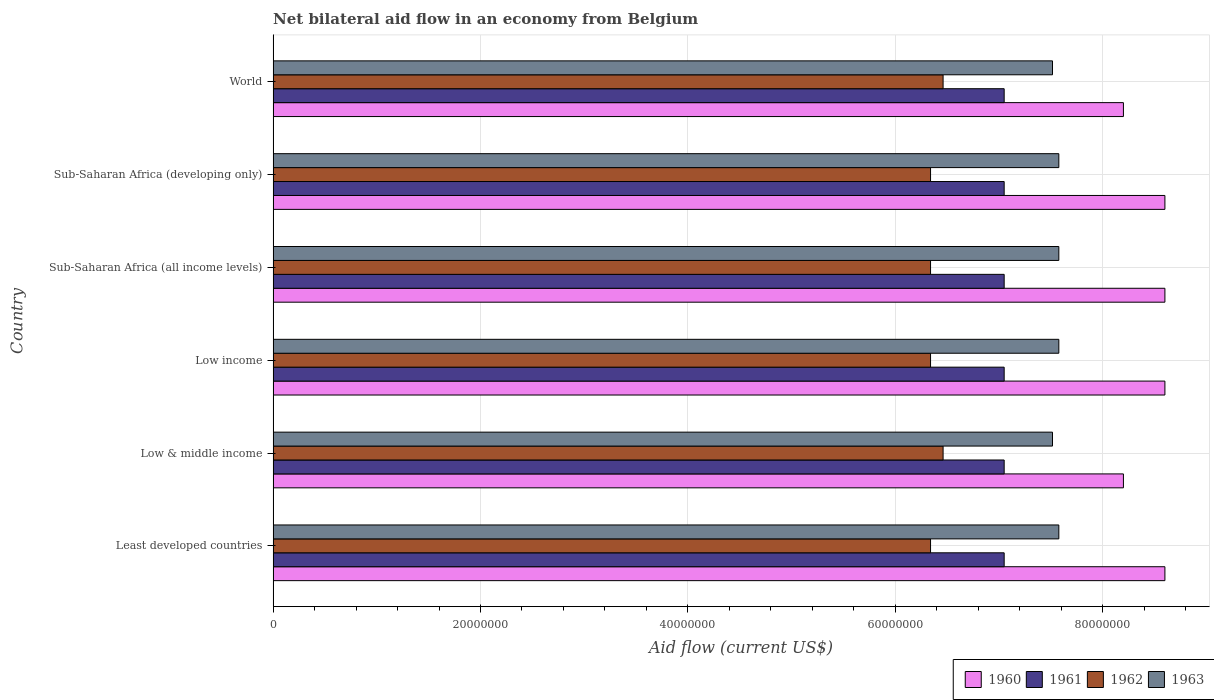How many different coloured bars are there?
Provide a short and direct response. 4. Are the number of bars per tick equal to the number of legend labels?
Offer a terse response. Yes. Are the number of bars on each tick of the Y-axis equal?
Ensure brevity in your answer.  Yes. What is the label of the 4th group of bars from the top?
Provide a short and direct response. Low income. In how many cases, is the number of bars for a given country not equal to the number of legend labels?
Offer a terse response. 0. What is the net bilateral aid flow in 1960 in Low & middle income?
Offer a terse response. 8.20e+07. Across all countries, what is the maximum net bilateral aid flow in 1963?
Ensure brevity in your answer.  7.58e+07. Across all countries, what is the minimum net bilateral aid flow in 1962?
Provide a short and direct response. 6.34e+07. In which country was the net bilateral aid flow in 1963 maximum?
Your answer should be very brief. Least developed countries. What is the total net bilateral aid flow in 1960 in the graph?
Make the answer very short. 5.08e+08. What is the difference between the net bilateral aid flow in 1961 in World and the net bilateral aid flow in 1960 in Low income?
Your answer should be compact. -1.55e+07. What is the average net bilateral aid flow in 1960 per country?
Provide a short and direct response. 8.47e+07. What is the difference between the net bilateral aid flow in 1960 and net bilateral aid flow in 1961 in Sub-Saharan Africa (developing only)?
Give a very brief answer. 1.55e+07. In how many countries, is the net bilateral aid flow in 1961 greater than 64000000 US$?
Provide a short and direct response. 6. What is the difference between the highest and the second highest net bilateral aid flow in 1961?
Keep it short and to the point. 0. What is the difference between the highest and the lowest net bilateral aid flow in 1962?
Give a very brief answer. 1.21e+06. In how many countries, is the net bilateral aid flow in 1961 greater than the average net bilateral aid flow in 1961 taken over all countries?
Ensure brevity in your answer.  0. What does the 1st bar from the top in World represents?
Your answer should be very brief. 1963. How many bars are there?
Provide a short and direct response. 24. Are the values on the major ticks of X-axis written in scientific E-notation?
Your answer should be very brief. No. Does the graph contain grids?
Give a very brief answer. Yes. How are the legend labels stacked?
Your answer should be compact. Horizontal. What is the title of the graph?
Ensure brevity in your answer.  Net bilateral aid flow in an economy from Belgium. Does "1984" appear as one of the legend labels in the graph?
Keep it short and to the point. No. What is the label or title of the X-axis?
Give a very brief answer. Aid flow (current US$). What is the Aid flow (current US$) of 1960 in Least developed countries?
Your answer should be very brief. 8.60e+07. What is the Aid flow (current US$) of 1961 in Least developed countries?
Provide a succinct answer. 7.05e+07. What is the Aid flow (current US$) of 1962 in Least developed countries?
Ensure brevity in your answer.  6.34e+07. What is the Aid flow (current US$) in 1963 in Least developed countries?
Provide a short and direct response. 7.58e+07. What is the Aid flow (current US$) of 1960 in Low & middle income?
Make the answer very short. 8.20e+07. What is the Aid flow (current US$) of 1961 in Low & middle income?
Your response must be concise. 7.05e+07. What is the Aid flow (current US$) in 1962 in Low & middle income?
Make the answer very short. 6.46e+07. What is the Aid flow (current US$) in 1963 in Low & middle income?
Your response must be concise. 7.52e+07. What is the Aid flow (current US$) of 1960 in Low income?
Your answer should be very brief. 8.60e+07. What is the Aid flow (current US$) in 1961 in Low income?
Your answer should be compact. 7.05e+07. What is the Aid flow (current US$) in 1962 in Low income?
Ensure brevity in your answer.  6.34e+07. What is the Aid flow (current US$) in 1963 in Low income?
Your response must be concise. 7.58e+07. What is the Aid flow (current US$) of 1960 in Sub-Saharan Africa (all income levels)?
Offer a very short reply. 8.60e+07. What is the Aid flow (current US$) of 1961 in Sub-Saharan Africa (all income levels)?
Make the answer very short. 7.05e+07. What is the Aid flow (current US$) in 1962 in Sub-Saharan Africa (all income levels)?
Keep it short and to the point. 6.34e+07. What is the Aid flow (current US$) in 1963 in Sub-Saharan Africa (all income levels)?
Provide a short and direct response. 7.58e+07. What is the Aid flow (current US$) in 1960 in Sub-Saharan Africa (developing only)?
Your answer should be very brief. 8.60e+07. What is the Aid flow (current US$) in 1961 in Sub-Saharan Africa (developing only)?
Offer a terse response. 7.05e+07. What is the Aid flow (current US$) in 1962 in Sub-Saharan Africa (developing only)?
Give a very brief answer. 6.34e+07. What is the Aid flow (current US$) in 1963 in Sub-Saharan Africa (developing only)?
Provide a short and direct response. 7.58e+07. What is the Aid flow (current US$) of 1960 in World?
Your response must be concise. 8.20e+07. What is the Aid flow (current US$) in 1961 in World?
Offer a very short reply. 7.05e+07. What is the Aid flow (current US$) of 1962 in World?
Provide a short and direct response. 6.46e+07. What is the Aid flow (current US$) in 1963 in World?
Your answer should be compact. 7.52e+07. Across all countries, what is the maximum Aid flow (current US$) in 1960?
Your answer should be very brief. 8.60e+07. Across all countries, what is the maximum Aid flow (current US$) in 1961?
Offer a very short reply. 7.05e+07. Across all countries, what is the maximum Aid flow (current US$) of 1962?
Offer a terse response. 6.46e+07. Across all countries, what is the maximum Aid flow (current US$) in 1963?
Ensure brevity in your answer.  7.58e+07. Across all countries, what is the minimum Aid flow (current US$) in 1960?
Make the answer very short. 8.20e+07. Across all countries, what is the minimum Aid flow (current US$) in 1961?
Provide a short and direct response. 7.05e+07. Across all countries, what is the minimum Aid flow (current US$) in 1962?
Keep it short and to the point. 6.34e+07. Across all countries, what is the minimum Aid flow (current US$) in 1963?
Your response must be concise. 7.52e+07. What is the total Aid flow (current US$) of 1960 in the graph?
Provide a short and direct response. 5.08e+08. What is the total Aid flow (current US$) of 1961 in the graph?
Your answer should be very brief. 4.23e+08. What is the total Aid flow (current US$) in 1962 in the graph?
Your response must be concise. 3.83e+08. What is the total Aid flow (current US$) of 1963 in the graph?
Offer a terse response. 4.53e+08. What is the difference between the Aid flow (current US$) in 1960 in Least developed countries and that in Low & middle income?
Make the answer very short. 4.00e+06. What is the difference between the Aid flow (current US$) in 1961 in Least developed countries and that in Low & middle income?
Provide a short and direct response. 0. What is the difference between the Aid flow (current US$) in 1962 in Least developed countries and that in Low & middle income?
Provide a succinct answer. -1.21e+06. What is the difference between the Aid flow (current US$) of 1960 in Least developed countries and that in Low income?
Keep it short and to the point. 0. What is the difference between the Aid flow (current US$) of 1960 in Least developed countries and that in Sub-Saharan Africa (all income levels)?
Your answer should be compact. 0. What is the difference between the Aid flow (current US$) of 1961 in Least developed countries and that in Sub-Saharan Africa (all income levels)?
Your answer should be compact. 0. What is the difference between the Aid flow (current US$) in 1962 in Least developed countries and that in Sub-Saharan Africa (all income levels)?
Offer a very short reply. 0. What is the difference between the Aid flow (current US$) of 1963 in Least developed countries and that in Sub-Saharan Africa (all income levels)?
Keep it short and to the point. 0. What is the difference between the Aid flow (current US$) of 1960 in Least developed countries and that in Sub-Saharan Africa (developing only)?
Make the answer very short. 0. What is the difference between the Aid flow (current US$) of 1961 in Least developed countries and that in Sub-Saharan Africa (developing only)?
Offer a very short reply. 0. What is the difference between the Aid flow (current US$) of 1962 in Least developed countries and that in Sub-Saharan Africa (developing only)?
Provide a succinct answer. 0. What is the difference between the Aid flow (current US$) of 1962 in Least developed countries and that in World?
Make the answer very short. -1.21e+06. What is the difference between the Aid flow (current US$) of 1963 in Least developed countries and that in World?
Ensure brevity in your answer.  6.10e+05. What is the difference between the Aid flow (current US$) of 1960 in Low & middle income and that in Low income?
Give a very brief answer. -4.00e+06. What is the difference between the Aid flow (current US$) in 1961 in Low & middle income and that in Low income?
Provide a short and direct response. 0. What is the difference between the Aid flow (current US$) in 1962 in Low & middle income and that in Low income?
Offer a terse response. 1.21e+06. What is the difference between the Aid flow (current US$) in 1963 in Low & middle income and that in Low income?
Your answer should be very brief. -6.10e+05. What is the difference between the Aid flow (current US$) in 1961 in Low & middle income and that in Sub-Saharan Africa (all income levels)?
Keep it short and to the point. 0. What is the difference between the Aid flow (current US$) in 1962 in Low & middle income and that in Sub-Saharan Africa (all income levels)?
Your response must be concise. 1.21e+06. What is the difference between the Aid flow (current US$) of 1963 in Low & middle income and that in Sub-Saharan Africa (all income levels)?
Make the answer very short. -6.10e+05. What is the difference between the Aid flow (current US$) in 1960 in Low & middle income and that in Sub-Saharan Africa (developing only)?
Offer a very short reply. -4.00e+06. What is the difference between the Aid flow (current US$) in 1961 in Low & middle income and that in Sub-Saharan Africa (developing only)?
Your answer should be very brief. 0. What is the difference between the Aid flow (current US$) in 1962 in Low & middle income and that in Sub-Saharan Africa (developing only)?
Offer a very short reply. 1.21e+06. What is the difference between the Aid flow (current US$) of 1963 in Low & middle income and that in Sub-Saharan Africa (developing only)?
Offer a very short reply. -6.10e+05. What is the difference between the Aid flow (current US$) of 1961 in Low & middle income and that in World?
Give a very brief answer. 0. What is the difference between the Aid flow (current US$) of 1963 in Low & middle income and that in World?
Keep it short and to the point. 0. What is the difference between the Aid flow (current US$) in 1961 in Low income and that in Sub-Saharan Africa (all income levels)?
Your response must be concise. 0. What is the difference between the Aid flow (current US$) in 1962 in Low income and that in Sub-Saharan Africa (all income levels)?
Give a very brief answer. 0. What is the difference between the Aid flow (current US$) in 1963 in Low income and that in Sub-Saharan Africa (all income levels)?
Offer a terse response. 0. What is the difference between the Aid flow (current US$) in 1960 in Low income and that in Sub-Saharan Africa (developing only)?
Give a very brief answer. 0. What is the difference between the Aid flow (current US$) in 1961 in Low income and that in Sub-Saharan Africa (developing only)?
Keep it short and to the point. 0. What is the difference between the Aid flow (current US$) in 1962 in Low income and that in Sub-Saharan Africa (developing only)?
Provide a short and direct response. 0. What is the difference between the Aid flow (current US$) of 1962 in Low income and that in World?
Offer a terse response. -1.21e+06. What is the difference between the Aid flow (current US$) in 1960 in Sub-Saharan Africa (all income levels) and that in Sub-Saharan Africa (developing only)?
Ensure brevity in your answer.  0. What is the difference between the Aid flow (current US$) of 1961 in Sub-Saharan Africa (all income levels) and that in Sub-Saharan Africa (developing only)?
Keep it short and to the point. 0. What is the difference between the Aid flow (current US$) in 1962 in Sub-Saharan Africa (all income levels) and that in Sub-Saharan Africa (developing only)?
Offer a very short reply. 0. What is the difference between the Aid flow (current US$) of 1963 in Sub-Saharan Africa (all income levels) and that in Sub-Saharan Africa (developing only)?
Provide a short and direct response. 0. What is the difference between the Aid flow (current US$) of 1962 in Sub-Saharan Africa (all income levels) and that in World?
Your answer should be compact. -1.21e+06. What is the difference between the Aid flow (current US$) of 1962 in Sub-Saharan Africa (developing only) and that in World?
Give a very brief answer. -1.21e+06. What is the difference between the Aid flow (current US$) of 1963 in Sub-Saharan Africa (developing only) and that in World?
Ensure brevity in your answer.  6.10e+05. What is the difference between the Aid flow (current US$) in 1960 in Least developed countries and the Aid flow (current US$) in 1961 in Low & middle income?
Make the answer very short. 1.55e+07. What is the difference between the Aid flow (current US$) of 1960 in Least developed countries and the Aid flow (current US$) of 1962 in Low & middle income?
Provide a succinct answer. 2.14e+07. What is the difference between the Aid flow (current US$) in 1960 in Least developed countries and the Aid flow (current US$) in 1963 in Low & middle income?
Your answer should be compact. 1.08e+07. What is the difference between the Aid flow (current US$) in 1961 in Least developed countries and the Aid flow (current US$) in 1962 in Low & middle income?
Give a very brief answer. 5.89e+06. What is the difference between the Aid flow (current US$) in 1961 in Least developed countries and the Aid flow (current US$) in 1963 in Low & middle income?
Ensure brevity in your answer.  -4.66e+06. What is the difference between the Aid flow (current US$) in 1962 in Least developed countries and the Aid flow (current US$) in 1963 in Low & middle income?
Ensure brevity in your answer.  -1.18e+07. What is the difference between the Aid flow (current US$) of 1960 in Least developed countries and the Aid flow (current US$) of 1961 in Low income?
Offer a terse response. 1.55e+07. What is the difference between the Aid flow (current US$) of 1960 in Least developed countries and the Aid flow (current US$) of 1962 in Low income?
Your answer should be compact. 2.26e+07. What is the difference between the Aid flow (current US$) of 1960 in Least developed countries and the Aid flow (current US$) of 1963 in Low income?
Make the answer very short. 1.02e+07. What is the difference between the Aid flow (current US$) in 1961 in Least developed countries and the Aid flow (current US$) in 1962 in Low income?
Offer a terse response. 7.10e+06. What is the difference between the Aid flow (current US$) of 1961 in Least developed countries and the Aid flow (current US$) of 1963 in Low income?
Make the answer very short. -5.27e+06. What is the difference between the Aid flow (current US$) in 1962 in Least developed countries and the Aid flow (current US$) in 1963 in Low income?
Your response must be concise. -1.24e+07. What is the difference between the Aid flow (current US$) in 1960 in Least developed countries and the Aid flow (current US$) in 1961 in Sub-Saharan Africa (all income levels)?
Make the answer very short. 1.55e+07. What is the difference between the Aid flow (current US$) in 1960 in Least developed countries and the Aid flow (current US$) in 1962 in Sub-Saharan Africa (all income levels)?
Provide a short and direct response. 2.26e+07. What is the difference between the Aid flow (current US$) of 1960 in Least developed countries and the Aid flow (current US$) of 1963 in Sub-Saharan Africa (all income levels)?
Keep it short and to the point. 1.02e+07. What is the difference between the Aid flow (current US$) of 1961 in Least developed countries and the Aid flow (current US$) of 1962 in Sub-Saharan Africa (all income levels)?
Make the answer very short. 7.10e+06. What is the difference between the Aid flow (current US$) in 1961 in Least developed countries and the Aid flow (current US$) in 1963 in Sub-Saharan Africa (all income levels)?
Give a very brief answer. -5.27e+06. What is the difference between the Aid flow (current US$) in 1962 in Least developed countries and the Aid flow (current US$) in 1963 in Sub-Saharan Africa (all income levels)?
Provide a succinct answer. -1.24e+07. What is the difference between the Aid flow (current US$) in 1960 in Least developed countries and the Aid flow (current US$) in 1961 in Sub-Saharan Africa (developing only)?
Offer a very short reply. 1.55e+07. What is the difference between the Aid flow (current US$) of 1960 in Least developed countries and the Aid flow (current US$) of 1962 in Sub-Saharan Africa (developing only)?
Give a very brief answer. 2.26e+07. What is the difference between the Aid flow (current US$) of 1960 in Least developed countries and the Aid flow (current US$) of 1963 in Sub-Saharan Africa (developing only)?
Provide a succinct answer. 1.02e+07. What is the difference between the Aid flow (current US$) in 1961 in Least developed countries and the Aid flow (current US$) in 1962 in Sub-Saharan Africa (developing only)?
Give a very brief answer. 7.10e+06. What is the difference between the Aid flow (current US$) in 1961 in Least developed countries and the Aid flow (current US$) in 1963 in Sub-Saharan Africa (developing only)?
Ensure brevity in your answer.  -5.27e+06. What is the difference between the Aid flow (current US$) of 1962 in Least developed countries and the Aid flow (current US$) of 1963 in Sub-Saharan Africa (developing only)?
Keep it short and to the point. -1.24e+07. What is the difference between the Aid flow (current US$) in 1960 in Least developed countries and the Aid flow (current US$) in 1961 in World?
Ensure brevity in your answer.  1.55e+07. What is the difference between the Aid flow (current US$) of 1960 in Least developed countries and the Aid flow (current US$) of 1962 in World?
Your response must be concise. 2.14e+07. What is the difference between the Aid flow (current US$) in 1960 in Least developed countries and the Aid flow (current US$) in 1963 in World?
Ensure brevity in your answer.  1.08e+07. What is the difference between the Aid flow (current US$) of 1961 in Least developed countries and the Aid flow (current US$) of 1962 in World?
Provide a short and direct response. 5.89e+06. What is the difference between the Aid flow (current US$) in 1961 in Least developed countries and the Aid flow (current US$) in 1963 in World?
Your answer should be compact. -4.66e+06. What is the difference between the Aid flow (current US$) of 1962 in Least developed countries and the Aid flow (current US$) of 1963 in World?
Offer a very short reply. -1.18e+07. What is the difference between the Aid flow (current US$) of 1960 in Low & middle income and the Aid flow (current US$) of 1961 in Low income?
Your answer should be compact. 1.15e+07. What is the difference between the Aid flow (current US$) in 1960 in Low & middle income and the Aid flow (current US$) in 1962 in Low income?
Your answer should be compact. 1.86e+07. What is the difference between the Aid flow (current US$) in 1960 in Low & middle income and the Aid flow (current US$) in 1963 in Low income?
Make the answer very short. 6.23e+06. What is the difference between the Aid flow (current US$) in 1961 in Low & middle income and the Aid flow (current US$) in 1962 in Low income?
Your answer should be compact. 7.10e+06. What is the difference between the Aid flow (current US$) in 1961 in Low & middle income and the Aid flow (current US$) in 1963 in Low income?
Keep it short and to the point. -5.27e+06. What is the difference between the Aid flow (current US$) in 1962 in Low & middle income and the Aid flow (current US$) in 1963 in Low income?
Offer a terse response. -1.12e+07. What is the difference between the Aid flow (current US$) of 1960 in Low & middle income and the Aid flow (current US$) of 1961 in Sub-Saharan Africa (all income levels)?
Offer a terse response. 1.15e+07. What is the difference between the Aid flow (current US$) of 1960 in Low & middle income and the Aid flow (current US$) of 1962 in Sub-Saharan Africa (all income levels)?
Offer a terse response. 1.86e+07. What is the difference between the Aid flow (current US$) of 1960 in Low & middle income and the Aid flow (current US$) of 1963 in Sub-Saharan Africa (all income levels)?
Make the answer very short. 6.23e+06. What is the difference between the Aid flow (current US$) in 1961 in Low & middle income and the Aid flow (current US$) in 1962 in Sub-Saharan Africa (all income levels)?
Keep it short and to the point. 7.10e+06. What is the difference between the Aid flow (current US$) of 1961 in Low & middle income and the Aid flow (current US$) of 1963 in Sub-Saharan Africa (all income levels)?
Keep it short and to the point. -5.27e+06. What is the difference between the Aid flow (current US$) of 1962 in Low & middle income and the Aid flow (current US$) of 1963 in Sub-Saharan Africa (all income levels)?
Make the answer very short. -1.12e+07. What is the difference between the Aid flow (current US$) of 1960 in Low & middle income and the Aid flow (current US$) of 1961 in Sub-Saharan Africa (developing only)?
Your response must be concise. 1.15e+07. What is the difference between the Aid flow (current US$) of 1960 in Low & middle income and the Aid flow (current US$) of 1962 in Sub-Saharan Africa (developing only)?
Provide a short and direct response. 1.86e+07. What is the difference between the Aid flow (current US$) in 1960 in Low & middle income and the Aid flow (current US$) in 1963 in Sub-Saharan Africa (developing only)?
Provide a succinct answer. 6.23e+06. What is the difference between the Aid flow (current US$) of 1961 in Low & middle income and the Aid flow (current US$) of 1962 in Sub-Saharan Africa (developing only)?
Your answer should be very brief. 7.10e+06. What is the difference between the Aid flow (current US$) in 1961 in Low & middle income and the Aid flow (current US$) in 1963 in Sub-Saharan Africa (developing only)?
Your answer should be compact. -5.27e+06. What is the difference between the Aid flow (current US$) in 1962 in Low & middle income and the Aid flow (current US$) in 1963 in Sub-Saharan Africa (developing only)?
Make the answer very short. -1.12e+07. What is the difference between the Aid flow (current US$) in 1960 in Low & middle income and the Aid flow (current US$) in 1961 in World?
Offer a terse response. 1.15e+07. What is the difference between the Aid flow (current US$) in 1960 in Low & middle income and the Aid flow (current US$) in 1962 in World?
Offer a very short reply. 1.74e+07. What is the difference between the Aid flow (current US$) of 1960 in Low & middle income and the Aid flow (current US$) of 1963 in World?
Give a very brief answer. 6.84e+06. What is the difference between the Aid flow (current US$) of 1961 in Low & middle income and the Aid flow (current US$) of 1962 in World?
Provide a succinct answer. 5.89e+06. What is the difference between the Aid flow (current US$) of 1961 in Low & middle income and the Aid flow (current US$) of 1963 in World?
Make the answer very short. -4.66e+06. What is the difference between the Aid flow (current US$) of 1962 in Low & middle income and the Aid flow (current US$) of 1963 in World?
Ensure brevity in your answer.  -1.06e+07. What is the difference between the Aid flow (current US$) in 1960 in Low income and the Aid flow (current US$) in 1961 in Sub-Saharan Africa (all income levels)?
Provide a short and direct response. 1.55e+07. What is the difference between the Aid flow (current US$) of 1960 in Low income and the Aid flow (current US$) of 1962 in Sub-Saharan Africa (all income levels)?
Your response must be concise. 2.26e+07. What is the difference between the Aid flow (current US$) of 1960 in Low income and the Aid flow (current US$) of 1963 in Sub-Saharan Africa (all income levels)?
Make the answer very short. 1.02e+07. What is the difference between the Aid flow (current US$) in 1961 in Low income and the Aid flow (current US$) in 1962 in Sub-Saharan Africa (all income levels)?
Give a very brief answer. 7.10e+06. What is the difference between the Aid flow (current US$) of 1961 in Low income and the Aid flow (current US$) of 1963 in Sub-Saharan Africa (all income levels)?
Keep it short and to the point. -5.27e+06. What is the difference between the Aid flow (current US$) of 1962 in Low income and the Aid flow (current US$) of 1963 in Sub-Saharan Africa (all income levels)?
Your answer should be very brief. -1.24e+07. What is the difference between the Aid flow (current US$) in 1960 in Low income and the Aid flow (current US$) in 1961 in Sub-Saharan Africa (developing only)?
Your response must be concise. 1.55e+07. What is the difference between the Aid flow (current US$) of 1960 in Low income and the Aid flow (current US$) of 1962 in Sub-Saharan Africa (developing only)?
Offer a very short reply. 2.26e+07. What is the difference between the Aid flow (current US$) of 1960 in Low income and the Aid flow (current US$) of 1963 in Sub-Saharan Africa (developing only)?
Your answer should be compact. 1.02e+07. What is the difference between the Aid flow (current US$) in 1961 in Low income and the Aid flow (current US$) in 1962 in Sub-Saharan Africa (developing only)?
Your response must be concise. 7.10e+06. What is the difference between the Aid flow (current US$) of 1961 in Low income and the Aid flow (current US$) of 1963 in Sub-Saharan Africa (developing only)?
Ensure brevity in your answer.  -5.27e+06. What is the difference between the Aid flow (current US$) in 1962 in Low income and the Aid flow (current US$) in 1963 in Sub-Saharan Africa (developing only)?
Provide a short and direct response. -1.24e+07. What is the difference between the Aid flow (current US$) of 1960 in Low income and the Aid flow (current US$) of 1961 in World?
Your answer should be very brief. 1.55e+07. What is the difference between the Aid flow (current US$) of 1960 in Low income and the Aid flow (current US$) of 1962 in World?
Your answer should be compact. 2.14e+07. What is the difference between the Aid flow (current US$) of 1960 in Low income and the Aid flow (current US$) of 1963 in World?
Provide a succinct answer. 1.08e+07. What is the difference between the Aid flow (current US$) in 1961 in Low income and the Aid flow (current US$) in 1962 in World?
Ensure brevity in your answer.  5.89e+06. What is the difference between the Aid flow (current US$) in 1961 in Low income and the Aid flow (current US$) in 1963 in World?
Your response must be concise. -4.66e+06. What is the difference between the Aid flow (current US$) of 1962 in Low income and the Aid flow (current US$) of 1963 in World?
Keep it short and to the point. -1.18e+07. What is the difference between the Aid flow (current US$) in 1960 in Sub-Saharan Africa (all income levels) and the Aid flow (current US$) in 1961 in Sub-Saharan Africa (developing only)?
Ensure brevity in your answer.  1.55e+07. What is the difference between the Aid flow (current US$) of 1960 in Sub-Saharan Africa (all income levels) and the Aid flow (current US$) of 1962 in Sub-Saharan Africa (developing only)?
Your answer should be very brief. 2.26e+07. What is the difference between the Aid flow (current US$) of 1960 in Sub-Saharan Africa (all income levels) and the Aid flow (current US$) of 1963 in Sub-Saharan Africa (developing only)?
Provide a succinct answer. 1.02e+07. What is the difference between the Aid flow (current US$) of 1961 in Sub-Saharan Africa (all income levels) and the Aid flow (current US$) of 1962 in Sub-Saharan Africa (developing only)?
Ensure brevity in your answer.  7.10e+06. What is the difference between the Aid flow (current US$) in 1961 in Sub-Saharan Africa (all income levels) and the Aid flow (current US$) in 1963 in Sub-Saharan Africa (developing only)?
Give a very brief answer. -5.27e+06. What is the difference between the Aid flow (current US$) of 1962 in Sub-Saharan Africa (all income levels) and the Aid flow (current US$) of 1963 in Sub-Saharan Africa (developing only)?
Make the answer very short. -1.24e+07. What is the difference between the Aid flow (current US$) in 1960 in Sub-Saharan Africa (all income levels) and the Aid flow (current US$) in 1961 in World?
Provide a succinct answer. 1.55e+07. What is the difference between the Aid flow (current US$) of 1960 in Sub-Saharan Africa (all income levels) and the Aid flow (current US$) of 1962 in World?
Your answer should be compact. 2.14e+07. What is the difference between the Aid flow (current US$) of 1960 in Sub-Saharan Africa (all income levels) and the Aid flow (current US$) of 1963 in World?
Provide a short and direct response. 1.08e+07. What is the difference between the Aid flow (current US$) of 1961 in Sub-Saharan Africa (all income levels) and the Aid flow (current US$) of 1962 in World?
Ensure brevity in your answer.  5.89e+06. What is the difference between the Aid flow (current US$) in 1961 in Sub-Saharan Africa (all income levels) and the Aid flow (current US$) in 1963 in World?
Give a very brief answer. -4.66e+06. What is the difference between the Aid flow (current US$) in 1962 in Sub-Saharan Africa (all income levels) and the Aid flow (current US$) in 1963 in World?
Ensure brevity in your answer.  -1.18e+07. What is the difference between the Aid flow (current US$) in 1960 in Sub-Saharan Africa (developing only) and the Aid flow (current US$) in 1961 in World?
Make the answer very short. 1.55e+07. What is the difference between the Aid flow (current US$) in 1960 in Sub-Saharan Africa (developing only) and the Aid flow (current US$) in 1962 in World?
Keep it short and to the point. 2.14e+07. What is the difference between the Aid flow (current US$) of 1960 in Sub-Saharan Africa (developing only) and the Aid flow (current US$) of 1963 in World?
Your response must be concise. 1.08e+07. What is the difference between the Aid flow (current US$) in 1961 in Sub-Saharan Africa (developing only) and the Aid flow (current US$) in 1962 in World?
Ensure brevity in your answer.  5.89e+06. What is the difference between the Aid flow (current US$) of 1961 in Sub-Saharan Africa (developing only) and the Aid flow (current US$) of 1963 in World?
Offer a terse response. -4.66e+06. What is the difference between the Aid flow (current US$) in 1962 in Sub-Saharan Africa (developing only) and the Aid flow (current US$) in 1963 in World?
Keep it short and to the point. -1.18e+07. What is the average Aid flow (current US$) in 1960 per country?
Give a very brief answer. 8.47e+07. What is the average Aid flow (current US$) of 1961 per country?
Ensure brevity in your answer.  7.05e+07. What is the average Aid flow (current US$) of 1962 per country?
Provide a short and direct response. 6.38e+07. What is the average Aid flow (current US$) in 1963 per country?
Provide a succinct answer. 7.56e+07. What is the difference between the Aid flow (current US$) in 1960 and Aid flow (current US$) in 1961 in Least developed countries?
Offer a terse response. 1.55e+07. What is the difference between the Aid flow (current US$) in 1960 and Aid flow (current US$) in 1962 in Least developed countries?
Keep it short and to the point. 2.26e+07. What is the difference between the Aid flow (current US$) in 1960 and Aid flow (current US$) in 1963 in Least developed countries?
Keep it short and to the point. 1.02e+07. What is the difference between the Aid flow (current US$) of 1961 and Aid flow (current US$) of 1962 in Least developed countries?
Your answer should be compact. 7.10e+06. What is the difference between the Aid flow (current US$) in 1961 and Aid flow (current US$) in 1963 in Least developed countries?
Offer a very short reply. -5.27e+06. What is the difference between the Aid flow (current US$) of 1962 and Aid flow (current US$) of 1963 in Least developed countries?
Offer a very short reply. -1.24e+07. What is the difference between the Aid flow (current US$) of 1960 and Aid flow (current US$) of 1961 in Low & middle income?
Your answer should be very brief. 1.15e+07. What is the difference between the Aid flow (current US$) of 1960 and Aid flow (current US$) of 1962 in Low & middle income?
Provide a succinct answer. 1.74e+07. What is the difference between the Aid flow (current US$) of 1960 and Aid flow (current US$) of 1963 in Low & middle income?
Your response must be concise. 6.84e+06. What is the difference between the Aid flow (current US$) in 1961 and Aid flow (current US$) in 1962 in Low & middle income?
Keep it short and to the point. 5.89e+06. What is the difference between the Aid flow (current US$) of 1961 and Aid flow (current US$) of 1963 in Low & middle income?
Your answer should be compact. -4.66e+06. What is the difference between the Aid flow (current US$) in 1962 and Aid flow (current US$) in 1963 in Low & middle income?
Give a very brief answer. -1.06e+07. What is the difference between the Aid flow (current US$) in 1960 and Aid flow (current US$) in 1961 in Low income?
Keep it short and to the point. 1.55e+07. What is the difference between the Aid flow (current US$) in 1960 and Aid flow (current US$) in 1962 in Low income?
Offer a terse response. 2.26e+07. What is the difference between the Aid flow (current US$) of 1960 and Aid flow (current US$) of 1963 in Low income?
Your answer should be compact. 1.02e+07. What is the difference between the Aid flow (current US$) in 1961 and Aid flow (current US$) in 1962 in Low income?
Keep it short and to the point. 7.10e+06. What is the difference between the Aid flow (current US$) in 1961 and Aid flow (current US$) in 1963 in Low income?
Offer a terse response. -5.27e+06. What is the difference between the Aid flow (current US$) in 1962 and Aid flow (current US$) in 1963 in Low income?
Keep it short and to the point. -1.24e+07. What is the difference between the Aid flow (current US$) of 1960 and Aid flow (current US$) of 1961 in Sub-Saharan Africa (all income levels)?
Keep it short and to the point. 1.55e+07. What is the difference between the Aid flow (current US$) of 1960 and Aid flow (current US$) of 1962 in Sub-Saharan Africa (all income levels)?
Make the answer very short. 2.26e+07. What is the difference between the Aid flow (current US$) in 1960 and Aid flow (current US$) in 1963 in Sub-Saharan Africa (all income levels)?
Make the answer very short. 1.02e+07. What is the difference between the Aid flow (current US$) in 1961 and Aid flow (current US$) in 1962 in Sub-Saharan Africa (all income levels)?
Offer a very short reply. 7.10e+06. What is the difference between the Aid flow (current US$) in 1961 and Aid flow (current US$) in 1963 in Sub-Saharan Africa (all income levels)?
Offer a terse response. -5.27e+06. What is the difference between the Aid flow (current US$) of 1962 and Aid flow (current US$) of 1963 in Sub-Saharan Africa (all income levels)?
Your answer should be very brief. -1.24e+07. What is the difference between the Aid flow (current US$) in 1960 and Aid flow (current US$) in 1961 in Sub-Saharan Africa (developing only)?
Give a very brief answer. 1.55e+07. What is the difference between the Aid flow (current US$) in 1960 and Aid flow (current US$) in 1962 in Sub-Saharan Africa (developing only)?
Offer a terse response. 2.26e+07. What is the difference between the Aid flow (current US$) in 1960 and Aid flow (current US$) in 1963 in Sub-Saharan Africa (developing only)?
Your response must be concise. 1.02e+07. What is the difference between the Aid flow (current US$) of 1961 and Aid flow (current US$) of 1962 in Sub-Saharan Africa (developing only)?
Ensure brevity in your answer.  7.10e+06. What is the difference between the Aid flow (current US$) of 1961 and Aid flow (current US$) of 1963 in Sub-Saharan Africa (developing only)?
Your response must be concise. -5.27e+06. What is the difference between the Aid flow (current US$) of 1962 and Aid flow (current US$) of 1963 in Sub-Saharan Africa (developing only)?
Ensure brevity in your answer.  -1.24e+07. What is the difference between the Aid flow (current US$) in 1960 and Aid flow (current US$) in 1961 in World?
Offer a terse response. 1.15e+07. What is the difference between the Aid flow (current US$) of 1960 and Aid flow (current US$) of 1962 in World?
Keep it short and to the point. 1.74e+07. What is the difference between the Aid flow (current US$) of 1960 and Aid flow (current US$) of 1963 in World?
Offer a very short reply. 6.84e+06. What is the difference between the Aid flow (current US$) of 1961 and Aid flow (current US$) of 1962 in World?
Your answer should be very brief. 5.89e+06. What is the difference between the Aid flow (current US$) in 1961 and Aid flow (current US$) in 1963 in World?
Offer a very short reply. -4.66e+06. What is the difference between the Aid flow (current US$) in 1962 and Aid flow (current US$) in 1963 in World?
Offer a very short reply. -1.06e+07. What is the ratio of the Aid flow (current US$) of 1960 in Least developed countries to that in Low & middle income?
Ensure brevity in your answer.  1.05. What is the ratio of the Aid flow (current US$) in 1962 in Least developed countries to that in Low & middle income?
Offer a terse response. 0.98. What is the ratio of the Aid flow (current US$) in 1962 in Least developed countries to that in Low income?
Keep it short and to the point. 1. What is the ratio of the Aid flow (current US$) in 1960 in Least developed countries to that in Sub-Saharan Africa (all income levels)?
Make the answer very short. 1. What is the ratio of the Aid flow (current US$) of 1962 in Least developed countries to that in Sub-Saharan Africa (all income levels)?
Your answer should be compact. 1. What is the ratio of the Aid flow (current US$) of 1963 in Least developed countries to that in Sub-Saharan Africa (developing only)?
Make the answer very short. 1. What is the ratio of the Aid flow (current US$) of 1960 in Least developed countries to that in World?
Offer a very short reply. 1.05. What is the ratio of the Aid flow (current US$) of 1962 in Least developed countries to that in World?
Offer a terse response. 0.98. What is the ratio of the Aid flow (current US$) of 1963 in Least developed countries to that in World?
Give a very brief answer. 1.01. What is the ratio of the Aid flow (current US$) of 1960 in Low & middle income to that in Low income?
Provide a succinct answer. 0.95. What is the ratio of the Aid flow (current US$) in 1961 in Low & middle income to that in Low income?
Your answer should be very brief. 1. What is the ratio of the Aid flow (current US$) of 1962 in Low & middle income to that in Low income?
Give a very brief answer. 1.02. What is the ratio of the Aid flow (current US$) of 1963 in Low & middle income to that in Low income?
Ensure brevity in your answer.  0.99. What is the ratio of the Aid flow (current US$) of 1960 in Low & middle income to that in Sub-Saharan Africa (all income levels)?
Ensure brevity in your answer.  0.95. What is the ratio of the Aid flow (current US$) in 1962 in Low & middle income to that in Sub-Saharan Africa (all income levels)?
Offer a terse response. 1.02. What is the ratio of the Aid flow (current US$) of 1963 in Low & middle income to that in Sub-Saharan Africa (all income levels)?
Ensure brevity in your answer.  0.99. What is the ratio of the Aid flow (current US$) of 1960 in Low & middle income to that in Sub-Saharan Africa (developing only)?
Give a very brief answer. 0.95. What is the ratio of the Aid flow (current US$) in 1961 in Low & middle income to that in Sub-Saharan Africa (developing only)?
Give a very brief answer. 1. What is the ratio of the Aid flow (current US$) of 1962 in Low & middle income to that in Sub-Saharan Africa (developing only)?
Give a very brief answer. 1.02. What is the ratio of the Aid flow (current US$) of 1961 in Low & middle income to that in World?
Provide a succinct answer. 1. What is the ratio of the Aid flow (current US$) in 1962 in Low & middle income to that in World?
Your answer should be very brief. 1. What is the ratio of the Aid flow (current US$) in 1963 in Low & middle income to that in World?
Provide a short and direct response. 1. What is the ratio of the Aid flow (current US$) in 1960 in Low income to that in Sub-Saharan Africa (all income levels)?
Provide a short and direct response. 1. What is the ratio of the Aid flow (current US$) in 1961 in Low income to that in Sub-Saharan Africa (all income levels)?
Your answer should be compact. 1. What is the ratio of the Aid flow (current US$) of 1962 in Low income to that in Sub-Saharan Africa (all income levels)?
Your response must be concise. 1. What is the ratio of the Aid flow (current US$) of 1960 in Low income to that in Sub-Saharan Africa (developing only)?
Keep it short and to the point. 1. What is the ratio of the Aid flow (current US$) in 1961 in Low income to that in Sub-Saharan Africa (developing only)?
Your answer should be very brief. 1. What is the ratio of the Aid flow (current US$) in 1960 in Low income to that in World?
Ensure brevity in your answer.  1.05. What is the ratio of the Aid flow (current US$) in 1962 in Low income to that in World?
Your answer should be compact. 0.98. What is the ratio of the Aid flow (current US$) in 1963 in Low income to that in World?
Provide a succinct answer. 1.01. What is the ratio of the Aid flow (current US$) of 1962 in Sub-Saharan Africa (all income levels) to that in Sub-Saharan Africa (developing only)?
Give a very brief answer. 1. What is the ratio of the Aid flow (current US$) in 1960 in Sub-Saharan Africa (all income levels) to that in World?
Keep it short and to the point. 1.05. What is the ratio of the Aid flow (current US$) in 1962 in Sub-Saharan Africa (all income levels) to that in World?
Your response must be concise. 0.98. What is the ratio of the Aid flow (current US$) of 1963 in Sub-Saharan Africa (all income levels) to that in World?
Ensure brevity in your answer.  1.01. What is the ratio of the Aid flow (current US$) in 1960 in Sub-Saharan Africa (developing only) to that in World?
Make the answer very short. 1.05. What is the ratio of the Aid flow (current US$) of 1962 in Sub-Saharan Africa (developing only) to that in World?
Offer a very short reply. 0.98. What is the ratio of the Aid flow (current US$) of 1963 in Sub-Saharan Africa (developing only) to that in World?
Your response must be concise. 1.01. What is the difference between the highest and the second highest Aid flow (current US$) in 1961?
Make the answer very short. 0. What is the difference between the highest and the second highest Aid flow (current US$) of 1962?
Your answer should be compact. 0. What is the difference between the highest and the lowest Aid flow (current US$) of 1960?
Provide a short and direct response. 4.00e+06. What is the difference between the highest and the lowest Aid flow (current US$) in 1961?
Give a very brief answer. 0. What is the difference between the highest and the lowest Aid flow (current US$) in 1962?
Keep it short and to the point. 1.21e+06. 